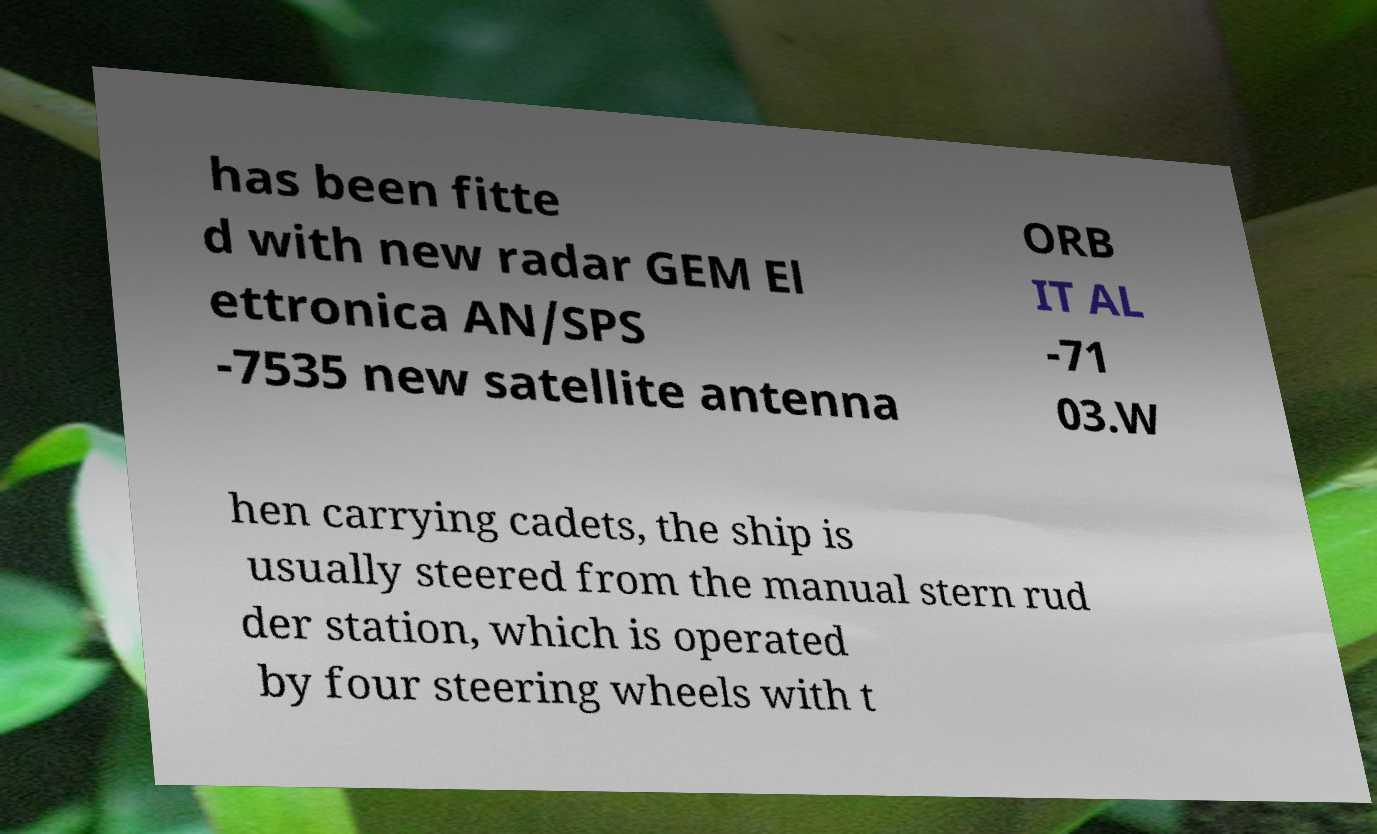Please identify and transcribe the text found in this image. has been fitte d with new radar GEM El ettronica AN/SPS -7535 new satellite antenna ORB IT AL -71 03.W hen carrying cadets, the ship is usually steered from the manual stern rud der station, which is operated by four steering wheels with t 